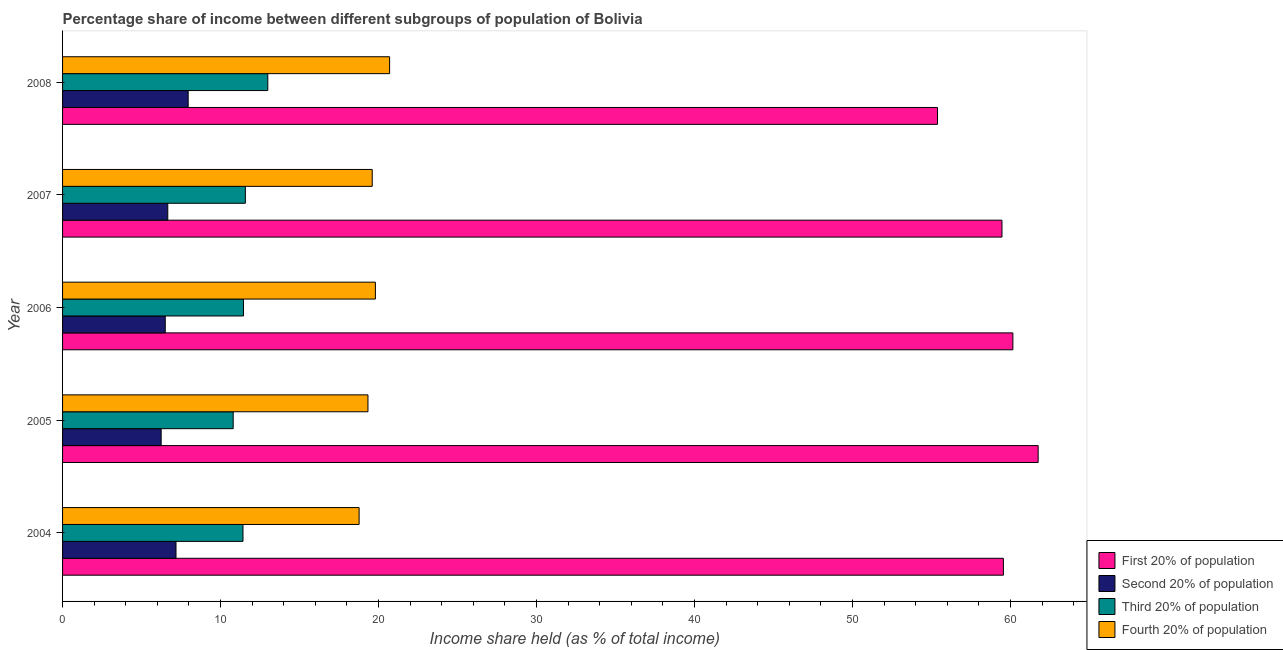Are the number of bars per tick equal to the number of legend labels?
Keep it short and to the point. Yes. How many bars are there on the 4th tick from the bottom?
Offer a terse response. 4. In how many cases, is the number of bars for a given year not equal to the number of legend labels?
Make the answer very short. 0. What is the share of the income held by first 20% of the population in 2007?
Provide a succinct answer. 59.46. Across all years, what is the maximum share of the income held by third 20% of the population?
Ensure brevity in your answer.  12.99. Across all years, what is the minimum share of the income held by fourth 20% of the population?
Provide a short and direct response. 18.77. What is the total share of the income held by first 20% of the population in the graph?
Offer a very short reply. 296.29. What is the difference between the share of the income held by third 20% of the population in 2005 and that in 2008?
Your response must be concise. -2.19. What is the difference between the share of the income held by fourth 20% of the population in 2005 and the share of the income held by first 20% of the population in 2004?
Offer a terse response. -40.22. What is the average share of the income held by fourth 20% of the population per year?
Ensure brevity in your answer.  19.64. In the year 2007, what is the difference between the share of the income held by first 20% of the population and share of the income held by fourth 20% of the population?
Keep it short and to the point. 39.86. What is the ratio of the share of the income held by fourth 20% of the population in 2004 to that in 2007?
Make the answer very short. 0.96. Is the share of the income held by third 20% of the population in 2006 less than that in 2007?
Make the answer very short. Yes. Is the difference between the share of the income held by second 20% of the population in 2004 and 2008 greater than the difference between the share of the income held by first 20% of the population in 2004 and 2008?
Offer a terse response. No. What is the difference between the highest and the second highest share of the income held by first 20% of the population?
Your response must be concise. 1.6. What is the difference between the highest and the lowest share of the income held by fourth 20% of the population?
Your response must be concise. 1.93. In how many years, is the share of the income held by third 20% of the population greater than the average share of the income held by third 20% of the population taken over all years?
Provide a succinct answer. 1. Is the sum of the share of the income held by first 20% of the population in 2004 and 2006 greater than the maximum share of the income held by fourth 20% of the population across all years?
Your answer should be compact. Yes. Is it the case that in every year, the sum of the share of the income held by fourth 20% of the population and share of the income held by first 20% of the population is greater than the sum of share of the income held by second 20% of the population and share of the income held by third 20% of the population?
Your answer should be compact. No. What does the 3rd bar from the top in 2008 represents?
Your answer should be compact. Second 20% of population. What does the 3rd bar from the bottom in 2004 represents?
Your answer should be compact. Third 20% of population. Are all the bars in the graph horizontal?
Give a very brief answer. Yes. Does the graph contain any zero values?
Make the answer very short. No. Where does the legend appear in the graph?
Your response must be concise. Bottom right. How many legend labels are there?
Your answer should be very brief. 4. What is the title of the graph?
Provide a short and direct response. Percentage share of income between different subgroups of population of Bolivia. Does "Overall level" appear as one of the legend labels in the graph?
Your response must be concise. No. What is the label or title of the X-axis?
Offer a terse response. Income share held (as % of total income). What is the Income share held (as % of total income) of First 20% of population in 2004?
Provide a short and direct response. 59.55. What is the Income share held (as % of total income) of Second 20% of population in 2004?
Ensure brevity in your answer.  7.18. What is the Income share held (as % of total income) in Third 20% of population in 2004?
Provide a short and direct response. 11.42. What is the Income share held (as % of total income) of Fourth 20% of population in 2004?
Provide a short and direct response. 18.77. What is the Income share held (as % of total income) in First 20% of population in 2005?
Your answer should be compact. 61.75. What is the Income share held (as % of total income) of Second 20% of population in 2005?
Give a very brief answer. 6.24. What is the Income share held (as % of total income) of Fourth 20% of population in 2005?
Your response must be concise. 19.33. What is the Income share held (as % of total income) in First 20% of population in 2006?
Your answer should be very brief. 60.15. What is the Income share held (as % of total income) of Second 20% of population in 2006?
Make the answer very short. 6.5. What is the Income share held (as % of total income) of Third 20% of population in 2006?
Keep it short and to the point. 11.45. What is the Income share held (as % of total income) in Fourth 20% of population in 2006?
Offer a terse response. 19.8. What is the Income share held (as % of total income) of First 20% of population in 2007?
Provide a succinct answer. 59.46. What is the Income share held (as % of total income) of Second 20% of population in 2007?
Ensure brevity in your answer.  6.66. What is the Income share held (as % of total income) in Third 20% of population in 2007?
Your response must be concise. 11.57. What is the Income share held (as % of total income) of Fourth 20% of population in 2007?
Your answer should be compact. 19.6. What is the Income share held (as % of total income) in First 20% of population in 2008?
Your answer should be compact. 55.38. What is the Income share held (as % of total income) in Second 20% of population in 2008?
Your response must be concise. 7.95. What is the Income share held (as % of total income) of Third 20% of population in 2008?
Offer a very short reply. 12.99. What is the Income share held (as % of total income) of Fourth 20% of population in 2008?
Offer a very short reply. 20.7. Across all years, what is the maximum Income share held (as % of total income) in First 20% of population?
Ensure brevity in your answer.  61.75. Across all years, what is the maximum Income share held (as % of total income) in Second 20% of population?
Your answer should be very brief. 7.95. Across all years, what is the maximum Income share held (as % of total income) of Third 20% of population?
Provide a short and direct response. 12.99. Across all years, what is the maximum Income share held (as % of total income) of Fourth 20% of population?
Provide a succinct answer. 20.7. Across all years, what is the minimum Income share held (as % of total income) in First 20% of population?
Your answer should be compact. 55.38. Across all years, what is the minimum Income share held (as % of total income) of Second 20% of population?
Keep it short and to the point. 6.24. Across all years, what is the minimum Income share held (as % of total income) in Third 20% of population?
Provide a short and direct response. 10.8. Across all years, what is the minimum Income share held (as % of total income) in Fourth 20% of population?
Keep it short and to the point. 18.77. What is the total Income share held (as % of total income) in First 20% of population in the graph?
Provide a short and direct response. 296.29. What is the total Income share held (as % of total income) in Second 20% of population in the graph?
Provide a succinct answer. 34.53. What is the total Income share held (as % of total income) of Third 20% of population in the graph?
Your answer should be compact. 58.23. What is the total Income share held (as % of total income) in Fourth 20% of population in the graph?
Your answer should be compact. 98.2. What is the difference between the Income share held (as % of total income) of Second 20% of population in 2004 and that in 2005?
Offer a terse response. 0.94. What is the difference between the Income share held (as % of total income) of Third 20% of population in 2004 and that in 2005?
Give a very brief answer. 0.62. What is the difference between the Income share held (as % of total income) in Fourth 20% of population in 2004 and that in 2005?
Ensure brevity in your answer.  -0.56. What is the difference between the Income share held (as % of total income) of Second 20% of population in 2004 and that in 2006?
Offer a very short reply. 0.68. What is the difference between the Income share held (as % of total income) of Third 20% of population in 2004 and that in 2006?
Offer a terse response. -0.03. What is the difference between the Income share held (as % of total income) of Fourth 20% of population in 2004 and that in 2006?
Keep it short and to the point. -1.03. What is the difference between the Income share held (as % of total income) of First 20% of population in 2004 and that in 2007?
Make the answer very short. 0.09. What is the difference between the Income share held (as % of total income) of Second 20% of population in 2004 and that in 2007?
Your answer should be very brief. 0.52. What is the difference between the Income share held (as % of total income) in Third 20% of population in 2004 and that in 2007?
Make the answer very short. -0.15. What is the difference between the Income share held (as % of total income) in Fourth 20% of population in 2004 and that in 2007?
Offer a very short reply. -0.83. What is the difference between the Income share held (as % of total income) of First 20% of population in 2004 and that in 2008?
Ensure brevity in your answer.  4.17. What is the difference between the Income share held (as % of total income) of Second 20% of population in 2004 and that in 2008?
Offer a terse response. -0.77. What is the difference between the Income share held (as % of total income) of Third 20% of population in 2004 and that in 2008?
Your answer should be very brief. -1.57. What is the difference between the Income share held (as % of total income) in Fourth 20% of population in 2004 and that in 2008?
Your answer should be very brief. -1.93. What is the difference between the Income share held (as % of total income) of Second 20% of population in 2005 and that in 2006?
Keep it short and to the point. -0.26. What is the difference between the Income share held (as % of total income) of Third 20% of population in 2005 and that in 2006?
Offer a very short reply. -0.65. What is the difference between the Income share held (as % of total income) of Fourth 20% of population in 2005 and that in 2006?
Keep it short and to the point. -0.47. What is the difference between the Income share held (as % of total income) of First 20% of population in 2005 and that in 2007?
Offer a terse response. 2.29. What is the difference between the Income share held (as % of total income) in Second 20% of population in 2005 and that in 2007?
Give a very brief answer. -0.42. What is the difference between the Income share held (as % of total income) of Third 20% of population in 2005 and that in 2007?
Your response must be concise. -0.77. What is the difference between the Income share held (as % of total income) of Fourth 20% of population in 2005 and that in 2007?
Your answer should be compact. -0.27. What is the difference between the Income share held (as % of total income) of First 20% of population in 2005 and that in 2008?
Offer a very short reply. 6.37. What is the difference between the Income share held (as % of total income) in Second 20% of population in 2005 and that in 2008?
Your answer should be very brief. -1.71. What is the difference between the Income share held (as % of total income) in Third 20% of population in 2005 and that in 2008?
Provide a short and direct response. -2.19. What is the difference between the Income share held (as % of total income) of Fourth 20% of population in 2005 and that in 2008?
Provide a succinct answer. -1.37. What is the difference between the Income share held (as % of total income) in First 20% of population in 2006 and that in 2007?
Provide a short and direct response. 0.69. What is the difference between the Income share held (as % of total income) in Second 20% of population in 2006 and that in 2007?
Your answer should be very brief. -0.16. What is the difference between the Income share held (as % of total income) in Third 20% of population in 2006 and that in 2007?
Offer a terse response. -0.12. What is the difference between the Income share held (as % of total income) in First 20% of population in 2006 and that in 2008?
Offer a terse response. 4.77. What is the difference between the Income share held (as % of total income) in Second 20% of population in 2006 and that in 2008?
Offer a terse response. -1.45. What is the difference between the Income share held (as % of total income) of Third 20% of population in 2006 and that in 2008?
Offer a terse response. -1.54. What is the difference between the Income share held (as % of total income) in Fourth 20% of population in 2006 and that in 2008?
Your answer should be very brief. -0.9. What is the difference between the Income share held (as % of total income) of First 20% of population in 2007 and that in 2008?
Make the answer very short. 4.08. What is the difference between the Income share held (as % of total income) in Second 20% of population in 2007 and that in 2008?
Provide a succinct answer. -1.29. What is the difference between the Income share held (as % of total income) of Third 20% of population in 2007 and that in 2008?
Give a very brief answer. -1.42. What is the difference between the Income share held (as % of total income) in Fourth 20% of population in 2007 and that in 2008?
Provide a short and direct response. -1.1. What is the difference between the Income share held (as % of total income) of First 20% of population in 2004 and the Income share held (as % of total income) of Second 20% of population in 2005?
Offer a very short reply. 53.31. What is the difference between the Income share held (as % of total income) of First 20% of population in 2004 and the Income share held (as % of total income) of Third 20% of population in 2005?
Your answer should be very brief. 48.75. What is the difference between the Income share held (as % of total income) in First 20% of population in 2004 and the Income share held (as % of total income) in Fourth 20% of population in 2005?
Ensure brevity in your answer.  40.22. What is the difference between the Income share held (as % of total income) in Second 20% of population in 2004 and the Income share held (as % of total income) in Third 20% of population in 2005?
Your answer should be compact. -3.62. What is the difference between the Income share held (as % of total income) of Second 20% of population in 2004 and the Income share held (as % of total income) of Fourth 20% of population in 2005?
Give a very brief answer. -12.15. What is the difference between the Income share held (as % of total income) in Third 20% of population in 2004 and the Income share held (as % of total income) in Fourth 20% of population in 2005?
Ensure brevity in your answer.  -7.91. What is the difference between the Income share held (as % of total income) in First 20% of population in 2004 and the Income share held (as % of total income) in Second 20% of population in 2006?
Offer a terse response. 53.05. What is the difference between the Income share held (as % of total income) in First 20% of population in 2004 and the Income share held (as % of total income) in Third 20% of population in 2006?
Offer a very short reply. 48.1. What is the difference between the Income share held (as % of total income) of First 20% of population in 2004 and the Income share held (as % of total income) of Fourth 20% of population in 2006?
Make the answer very short. 39.75. What is the difference between the Income share held (as % of total income) in Second 20% of population in 2004 and the Income share held (as % of total income) in Third 20% of population in 2006?
Make the answer very short. -4.27. What is the difference between the Income share held (as % of total income) of Second 20% of population in 2004 and the Income share held (as % of total income) of Fourth 20% of population in 2006?
Offer a very short reply. -12.62. What is the difference between the Income share held (as % of total income) in Third 20% of population in 2004 and the Income share held (as % of total income) in Fourth 20% of population in 2006?
Your answer should be very brief. -8.38. What is the difference between the Income share held (as % of total income) of First 20% of population in 2004 and the Income share held (as % of total income) of Second 20% of population in 2007?
Your response must be concise. 52.89. What is the difference between the Income share held (as % of total income) of First 20% of population in 2004 and the Income share held (as % of total income) of Third 20% of population in 2007?
Provide a succinct answer. 47.98. What is the difference between the Income share held (as % of total income) of First 20% of population in 2004 and the Income share held (as % of total income) of Fourth 20% of population in 2007?
Your answer should be very brief. 39.95. What is the difference between the Income share held (as % of total income) of Second 20% of population in 2004 and the Income share held (as % of total income) of Third 20% of population in 2007?
Give a very brief answer. -4.39. What is the difference between the Income share held (as % of total income) of Second 20% of population in 2004 and the Income share held (as % of total income) of Fourth 20% of population in 2007?
Give a very brief answer. -12.42. What is the difference between the Income share held (as % of total income) in Third 20% of population in 2004 and the Income share held (as % of total income) in Fourth 20% of population in 2007?
Provide a short and direct response. -8.18. What is the difference between the Income share held (as % of total income) of First 20% of population in 2004 and the Income share held (as % of total income) of Second 20% of population in 2008?
Ensure brevity in your answer.  51.6. What is the difference between the Income share held (as % of total income) in First 20% of population in 2004 and the Income share held (as % of total income) in Third 20% of population in 2008?
Offer a very short reply. 46.56. What is the difference between the Income share held (as % of total income) of First 20% of population in 2004 and the Income share held (as % of total income) of Fourth 20% of population in 2008?
Ensure brevity in your answer.  38.85. What is the difference between the Income share held (as % of total income) in Second 20% of population in 2004 and the Income share held (as % of total income) in Third 20% of population in 2008?
Offer a very short reply. -5.81. What is the difference between the Income share held (as % of total income) of Second 20% of population in 2004 and the Income share held (as % of total income) of Fourth 20% of population in 2008?
Your answer should be very brief. -13.52. What is the difference between the Income share held (as % of total income) of Third 20% of population in 2004 and the Income share held (as % of total income) of Fourth 20% of population in 2008?
Your answer should be compact. -9.28. What is the difference between the Income share held (as % of total income) in First 20% of population in 2005 and the Income share held (as % of total income) in Second 20% of population in 2006?
Give a very brief answer. 55.25. What is the difference between the Income share held (as % of total income) in First 20% of population in 2005 and the Income share held (as % of total income) in Third 20% of population in 2006?
Provide a short and direct response. 50.3. What is the difference between the Income share held (as % of total income) in First 20% of population in 2005 and the Income share held (as % of total income) in Fourth 20% of population in 2006?
Provide a succinct answer. 41.95. What is the difference between the Income share held (as % of total income) in Second 20% of population in 2005 and the Income share held (as % of total income) in Third 20% of population in 2006?
Keep it short and to the point. -5.21. What is the difference between the Income share held (as % of total income) of Second 20% of population in 2005 and the Income share held (as % of total income) of Fourth 20% of population in 2006?
Your answer should be compact. -13.56. What is the difference between the Income share held (as % of total income) in Third 20% of population in 2005 and the Income share held (as % of total income) in Fourth 20% of population in 2006?
Provide a short and direct response. -9. What is the difference between the Income share held (as % of total income) of First 20% of population in 2005 and the Income share held (as % of total income) of Second 20% of population in 2007?
Offer a very short reply. 55.09. What is the difference between the Income share held (as % of total income) of First 20% of population in 2005 and the Income share held (as % of total income) of Third 20% of population in 2007?
Your answer should be very brief. 50.18. What is the difference between the Income share held (as % of total income) in First 20% of population in 2005 and the Income share held (as % of total income) in Fourth 20% of population in 2007?
Your answer should be compact. 42.15. What is the difference between the Income share held (as % of total income) of Second 20% of population in 2005 and the Income share held (as % of total income) of Third 20% of population in 2007?
Ensure brevity in your answer.  -5.33. What is the difference between the Income share held (as % of total income) of Second 20% of population in 2005 and the Income share held (as % of total income) of Fourth 20% of population in 2007?
Give a very brief answer. -13.36. What is the difference between the Income share held (as % of total income) of Third 20% of population in 2005 and the Income share held (as % of total income) of Fourth 20% of population in 2007?
Your answer should be compact. -8.8. What is the difference between the Income share held (as % of total income) of First 20% of population in 2005 and the Income share held (as % of total income) of Second 20% of population in 2008?
Your answer should be compact. 53.8. What is the difference between the Income share held (as % of total income) of First 20% of population in 2005 and the Income share held (as % of total income) of Third 20% of population in 2008?
Your answer should be very brief. 48.76. What is the difference between the Income share held (as % of total income) in First 20% of population in 2005 and the Income share held (as % of total income) in Fourth 20% of population in 2008?
Your answer should be very brief. 41.05. What is the difference between the Income share held (as % of total income) of Second 20% of population in 2005 and the Income share held (as % of total income) of Third 20% of population in 2008?
Make the answer very short. -6.75. What is the difference between the Income share held (as % of total income) of Second 20% of population in 2005 and the Income share held (as % of total income) of Fourth 20% of population in 2008?
Make the answer very short. -14.46. What is the difference between the Income share held (as % of total income) in First 20% of population in 2006 and the Income share held (as % of total income) in Second 20% of population in 2007?
Provide a succinct answer. 53.49. What is the difference between the Income share held (as % of total income) in First 20% of population in 2006 and the Income share held (as % of total income) in Third 20% of population in 2007?
Ensure brevity in your answer.  48.58. What is the difference between the Income share held (as % of total income) in First 20% of population in 2006 and the Income share held (as % of total income) in Fourth 20% of population in 2007?
Offer a terse response. 40.55. What is the difference between the Income share held (as % of total income) of Second 20% of population in 2006 and the Income share held (as % of total income) of Third 20% of population in 2007?
Keep it short and to the point. -5.07. What is the difference between the Income share held (as % of total income) in Third 20% of population in 2006 and the Income share held (as % of total income) in Fourth 20% of population in 2007?
Offer a very short reply. -8.15. What is the difference between the Income share held (as % of total income) in First 20% of population in 2006 and the Income share held (as % of total income) in Second 20% of population in 2008?
Your answer should be compact. 52.2. What is the difference between the Income share held (as % of total income) of First 20% of population in 2006 and the Income share held (as % of total income) of Third 20% of population in 2008?
Make the answer very short. 47.16. What is the difference between the Income share held (as % of total income) in First 20% of population in 2006 and the Income share held (as % of total income) in Fourth 20% of population in 2008?
Give a very brief answer. 39.45. What is the difference between the Income share held (as % of total income) in Second 20% of population in 2006 and the Income share held (as % of total income) in Third 20% of population in 2008?
Your response must be concise. -6.49. What is the difference between the Income share held (as % of total income) in Second 20% of population in 2006 and the Income share held (as % of total income) in Fourth 20% of population in 2008?
Ensure brevity in your answer.  -14.2. What is the difference between the Income share held (as % of total income) of Third 20% of population in 2006 and the Income share held (as % of total income) of Fourth 20% of population in 2008?
Your answer should be compact. -9.25. What is the difference between the Income share held (as % of total income) of First 20% of population in 2007 and the Income share held (as % of total income) of Second 20% of population in 2008?
Your response must be concise. 51.51. What is the difference between the Income share held (as % of total income) of First 20% of population in 2007 and the Income share held (as % of total income) of Third 20% of population in 2008?
Keep it short and to the point. 46.47. What is the difference between the Income share held (as % of total income) of First 20% of population in 2007 and the Income share held (as % of total income) of Fourth 20% of population in 2008?
Offer a very short reply. 38.76. What is the difference between the Income share held (as % of total income) of Second 20% of population in 2007 and the Income share held (as % of total income) of Third 20% of population in 2008?
Offer a very short reply. -6.33. What is the difference between the Income share held (as % of total income) of Second 20% of population in 2007 and the Income share held (as % of total income) of Fourth 20% of population in 2008?
Your answer should be very brief. -14.04. What is the difference between the Income share held (as % of total income) in Third 20% of population in 2007 and the Income share held (as % of total income) in Fourth 20% of population in 2008?
Your response must be concise. -9.13. What is the average Income share held (as % of total income) in First 20% of population per year?
Offer a very short reply. 59.26. What is the average Income share held (as % of total income) in Second 20% of population per year?
Make the answer very short. 6.91. What is the average Income share held (as % of total income) in Third 20% of population per year?
Provide a succinct answer. 11.65. What is the average Income share held (as % of total income) of Fourth 20% of population per year?
Provide a succinct answer. 19.64. In the year 2004, what is the difference between the Income share held (as % of total income) of First 20% of population and Income share held (as % of total income) of Second 20% of population?
Offer a very short reply. 52.37. In the year 2004, what is the difference between the Income share held (as % of total income) in First 20% of population and Income share held (as % of total income) in Third 20% of population?
Make the answer very short. 48.13. In the year 2004, what is the difference between the Income share held (as % of total income) of First 20% of population and Income share held (as % of total income) of Fourth 20% of population?
Your answer should be very brief. 40.78. In the year 2004, what is the difference between the Income share held (as % of total income) of Second 20% of population and Income share held (as % of total income) of Third 20% of population?
Offer a terse response. -4.24. In the year 2004, what is the difference between the Income share held (as % of total income) in Second 20% of population and Income share held (as % of total income) in Fourth 20% of population?
Make the answer very short. -11.59. In the year 2004, what is the difference between the Income share held (as % of total income) of Third 20% of population and Income share held (as % of total income) of Fourth 20% of population?
Provide a short and direct response. -7.35. In the year 2005, what is the difference between the Income share held (as % of total income) in First 20% of population and Income share held (as % of total income) in Second 20% of population?
Make the answer very short. 55.51. In the year 2005, what is the difference between the Income share held (as % of total income) in First 20% of population and Income share held (as % of total income) in Third 20% of population?
Provide a short and direct response. 50.95. In the year 2005, what is the difference between the Income share held (as % of total income) in First 20% of population and Income share held (as % of total income) in Fourth 20% of population?
Keep it short and to the point. 42.42. In the year 2005, what is the difference between the Income share held (as % of total income) of Second 20% of population and Income share held (as % of total income) of Third 20% of population?
Keep it short and to the point. -4.56. In the year 2005, what is the difference between the Income share held (as % of total income) in Second 20% of population and Income share held (as % of total income) in Fourth 20% of population?
Give a very brief answer. -13.09. In the year 2005, what is the difference between the Income share held (as % of total income) in Third 20% of population and Income share held (as % of total income) in Fourth 20% of population?
Your answer should be very brief. -8.53. In the year 2006, what is the difference between the Income share held (as % of total income) in First 20% of population and Income share held (as % of total income) in Second 20% of population?
Make the answer very short. 53.65. In the year 2006, what is the difference between the Income share held (as % of total income) in First 20% of population and Income share held (as % of total income) in Third 20% of population?
Keep it short and to the point. 48.7. In the year 2006, what is the difference between the Income share held (as % of total income) in First 20% of population and Income share held (as % of total income) in Fourth 20% of population?
Your answer should be compact. 40.35. In the year 2006, what is the difference between the Income share held (as % of total income) in Second 20% of population and Income share held (as % of total income) in Third 20% of population?
Offer a terse response. -4.95. In the year 2006, what is the difference between the Income share held (as % of total income) of Third 20% of population and Income share held (as % of total income) of Fourth 20% of population?
Offer a very short reply. -8.35. In the year 2007, what is the difference between the Income share held (as % of total income) of First 20% of population and Income share held (as % of total income) of Second 20% of population?
Your answer should be compact. 52.8. In the year 2007, what is the difference between the Income share held (as % of total income) in First 20% of population and Income share held (as % of total income) in Third 20% of population?
Ensure brevity in your answer.  47.89. In the year 2007, what is the difference between the Income share held (as % of total income) of First 20% of population and Income share held (as % of total income) of Fourth 20% of population?
Provide a short and direct response. 39.86. In the year 2007, what is the difference between the Income share held (as % of total income) of Second 20% of population and Income share held (as % of total income) of Third 20% of population?
Your answer should be very brief. -4.91. In the year 2007, what is the difference between the Income share held (as % of total income) of Second 20% of population and Income share held (as % of total income) of Fourth 20% of population?
Your answer should be very brief. -12.94. In the year 2007, what is the difference between the Income share held (as % of total income) in Third 20% of population and Income share held (as % of total income) in Fourth 20% of population?
Give a very brief answer. -8.03. In the year 2008, what is the difference between the Income share held (as % of total income) in First 20% of population and Income share held (as % of total income) in Second 20% of population?
Your response must be concise. 47.43. In the year 2008, what is the difference between the Income share held (as % of total income) in First 20% of population and Income share held (as % of total income) in Third 20% of population?
Your response must be concise. 42.39. In the year 2008, what is the difference between the Income share held (as % of total income) in First 20% of population and Income share held (as % of total income) in Fourth 20% of population?
Keep it short and to the point. 34.68. In the year 2008, what is the difference between the Income share held (as % of total income) in Second 20% of population and Income share held (as % of total income) in Third 20% of population?
Ensure brevity in your answer.  -5.04. In the year 2008, what is the difference between the Income share held (as % of total income) of Second 20% of population and Income share held (as % of total income) of Fourth 20% of population?
Keep it short and to the point. -12.75. In the year 2008, what is the difference between the Income share held (as % of total income) in Third 20% of population and Income share held (as % of total income) in Fourth 20% of population?
Provide a succinct answer. -7.71. What is the ratio of the Income share held (as % of total income) of First 20% of population in 2004 to that in 2005?
Give a very brief answer. 0.96. What is the ratio of the Income share held (as % of total income) of Second 20% of population in 2004 to that in 2005?
Keep it short and to the point. 1.15. What is the ratio of the Income share held (as % of total income) of Third 20% of population in 2004 to that in 2005?
Offer a very short reply. 1.06. What is the ratio of the Income share held (as % of total income) of First 20% of population in 2004 to that in 2006?
Provide a short and direct response. 0.99. What is the ratio of the Income share held (as % of total income) in Second 20% of population in 2004 to that in 2006?
Offer a terse response. 1.1. What is the ratio of the Income share held (as % of total income) of Third 20% of population in 2004 to that in 2006?
Your answer should be very brief. 1. What is the ratio of the Income share held (as % of total income) of Fourth 20% of population in 2004 to that in 2006?
Your answer should be very brief. 0.95. What is the ratio of the Income share held (as % of total income) of First 20% of population in 2004 to that in 2007?
Offer a very short reply. 1. What is the ratio of the Income share held (as % of total income) in Second 20% of population in 2004 to that in 2007?
Keep it short and to the point. 1.08. What is the ratio of the Income share held (as % of total income) of Fourth 20% of population in 2004 to that in 2007?
Your response must be concise. 0.96. What is the ratio of the Income share held (as % of total income) of First 20% of population in 2004 to that in 2008?
Make the answer very short. 1.08. What is the ratio of the Income share held (as % of total income) in Second 20% of population in 2004 to that in 2008?
Provide a short and direct response. 0.9. What is the ratio of the Income share held (as % of total income) in Third 20% of population in 2004 to that in 2008?
Offer a terse response. 0.88. What is the ratio of the Income share held (as % of total income) in Fourth 20% of population in 2004 to that in 2008?
Make the answer very short. 0.91. What is the ratio of the Income share held (as % of total income) in First 20% of population in 2005 to that in 2006?
Your response must be concise. 1.03. What is the ratio of the Income share held (as % of total income) in Second 20% of population in 2005 to that in 2006?
Your answer should be compact. 0.96. What is the ratio of the Income share held (as % of total income) of Third 20% of population in 2005 to that in 2006?
Ensure brevity in your answer.  0.94. What is the ratio of the Income share held (as % of total income) of Fourth 20% of population in 2005 to that in 2006?
Your answer should be compact. 0.98. What is the ratio of the Income share held (as % of total income) in First 20% of population in 2005 to that in 2007?
Offer a very short reply. 1.04. What is the ratio of the Income share held (as % of total income) in Second 20% of population in 2005 to that in 2007?
Ensure brevity in your answer.  0.94. What is the ratio of the Income share held (as % of total income) of Third 20% of population in 2005 to that in 2007?
Provide a succinct answer. 0.93. What is the ratio of the Income share held (as % of total income) in Fourth 20% of population in 2005 to that in 2007?
Provide a succinct answer. 0.99. What is the ratio of the Income share held (as % of total income) in First 20% of population in 2005 to that in 2008?
Provide a succinct answer. 1.11. What is the ratio of the Income share held (as % of total income) of Second 20% of population in 2005 to that in 2008?
Provide a short and direct response. 0.78. What is the ratio of the Income share held (as % of total income) in Third 20% of population in 2005 to that in 2008?
Make the answer very short. 0.83. What is the ratio of the Income share held (as % of total income) in Fourth 20% of population in 2005 to that in 2008?
Make the answer very short. 0.93. What is the ratio of the Income share held (as % of total income) of First 20% of population in 2006 to that in 2007?
Keep it short and to the point. 1.01. What is the ratio of the Income share held (as % of total income) in Second 20% of population in 2006 to that in 2007?
Ensure brevity in your answer.  0.98. What is the ratio of the Income share held (as % of total income) in Third 20% of population in 2006 to that in 2007?
Provide a short and direct response. 0.99. What is the ratio of the Income share held (as % of total income) of Fourth 20% of population in 2006 to that in 2007?
Give a very brief answer. 1.01. What is the ratio of the Income share held (as % of total income) in First 20% of population in 2006 to that in 2008?
Your answer should be very brief. 1.09. What is the ratio of the Income share held (as % of total income) in Second 20% of population in 2006 to that in 2008?
Ensure brevity in your answer.  0.82. What is the ratio of the Income share held (as % of total income) of Third 20% of population in 2006 to that in 2008?
Provide a succinct answer. 0.88. What is the ratio of the Income share held (as % of total income) in Fourth 20% of population in 2006 to that in 2008?
Your response must be concise. 0.96. What is the ratio of the Income share held (as % of total income) in First 20% of population in 2007 to that in 2008?
Provide a succinct answer. 1.07. What is the ratio of the Income share held (as % of total income) of Second 20% of population in 2007 to that in 2008?
Keep it short and to the point. 0.84. What is the ratio of the Income share held (as % of total income) in Third 20% of population in 2007 to that in 2008?
Offer a very short reply. 0.89. What is the ratio of the Income share held (as % of total income) of Fourth 20% of population in 2007 to that in 2008?
Provide a short and direct response. 0.95. What is the difference between the highest and the second highest Income share held (as % of total income) of Second 20% of population?
Give a very brief answer. 0.77. What is the difference between the highest and the second highest Income share held (as % of total income) of Third 20% of population?
Offer a very short reply. 1.42. What is the difference between the highest and the lowest Income share held (as % of total income) in First 20% of population?
Provide a short and direct response. 6.37. What is the difference between the highest and the lowest Income share held (as % of total income) of Second 20% of population?
Make the answer very short. 1.71. What is the difference between the highest and the lowest Income share held (as % of total income) in Third 20% of population?
Make the answer very short. 2.19. What is the difference between the highest and the lowest Income share held (as % of total income) of Fourth 20% of population?
Make the answer very short. 1.93. 